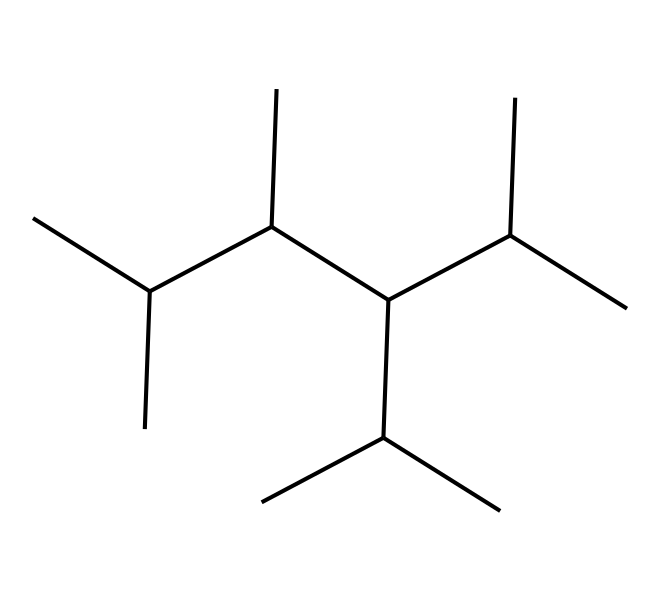What is the dominant element in the polypropylene fibers? The structure predominantly consists of carbon and hydrogen atoms, which are characteristic of hydrocarbons; therefore, the dominant element is carbon.
Answer: carbon How many carbon atoms are present in this chemical structure? By analyzing the SMILES representation, we count the number of 'C' symbols, which indicates there are 15 carbon atoms in the structure.
Answer: 15 What type of polymer is represented by this structure? This chemical structure corresponds to polypropylene, which is a type of thermoplastic polymer made from the polymerization of propylene monomers.
Answer: polypropylene What is the degree of branching suggested by the SMILES in this polymer? The presence of several branching points in the carbon chains suggests a highly branched structure, characteristic of isotactic or atactic polypropylene, which can enhance mechanical properties.
Answer: highly branched How does the molecular structure of this chemical contribute to its reinforcement properties in concrete? The long and branched carbon chains allow for extensive intermolecular interactions, enhancing bond strength and flexibility when incorporated in concrete, making it an effective reinforcement agent.
Answer: enhances strength 